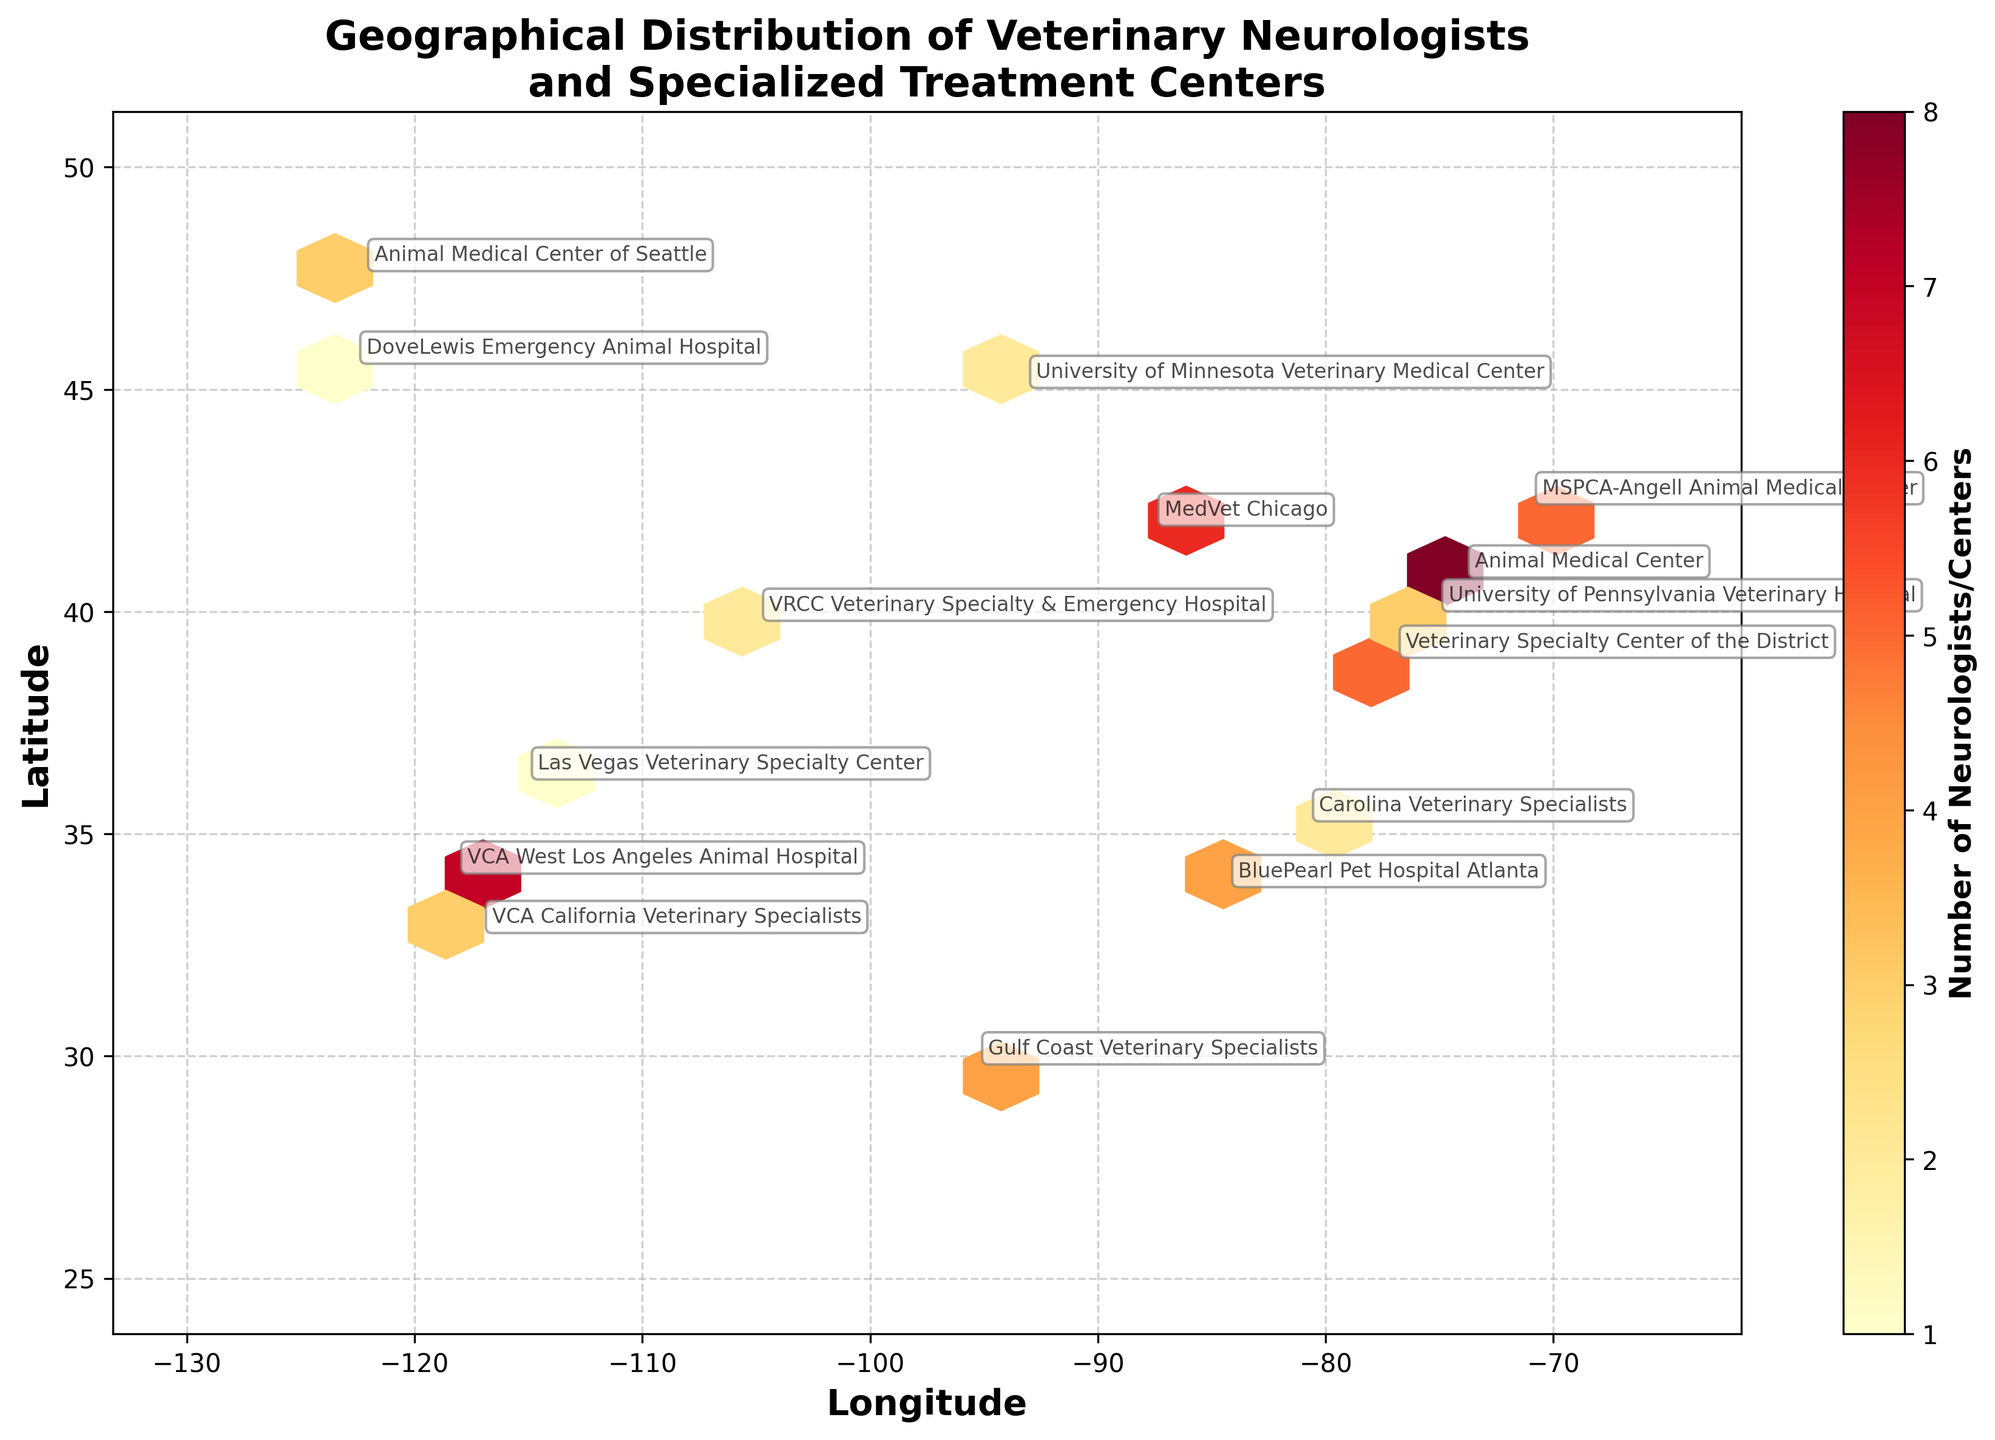What is the title of the figure? The title is typically located at the top of the figure and provides a brief description of what is being depicted. In this case, the title informs the viewer that the plot shows the geographical distribution of veterinary neurologists and specialized treatment centers for canine neurological disorders.
Answer: Geographical Distribution of Veterinary Neurologists and Specialized Treatment Centers What do the colors in the hexbin plot represent? The color intensity in a hexbin plot usually indicates the density or concentration of data points in a specific area. Here, darker colors likely represent a higher number of veterinary neurologists and specialized centers.
Answer: Number of Neurologists/Centers Which city has the highest concentration of veterinary neurologists and treatment centers? By identifying the darkest hexagon, which indicates the highest density, we can see that New York City (latitude 40.7128, longitude -74.0060) has the greatest concentration.
Answer: New York City How many centers are represented in Los Angeles according to the plot? By looking at the color gradient and annotations near Los Angeles (latitude 34.0522, longitude -118.2437), we find the label showing a number count.
Answer: 7 centers Which city shows a similar number of neurologists and treatment centers as Washington, D.C.? By comparing the data points, we can see that both Washington, D.C. (38.9072, -77.0369) and Boston (42.3601, -71.0589) have a count of 5, indicating a similar concentration.
Answer: Boston Are there more treatment centers on the East Coast or the West Coast? Summing the counts for cities like New York, Washington, D.C., Philadelphia, and Boston on the East Coast and comparing it with the counts for cities like Los Angeles, Seattle, San Diego, and Portland on the West Coast. The East Coast has more centers.
Answer: East Coast What is the hexagon grid size used in the plot, and how does it affect the visualization? The grid size parameter in a hexbin plot determines the number of hexagons used to divide the plot area; a smaller size would result in more hexagons and a finer resolution. The code specifies a grid size of 20.
Answer: 20; finer resolution Which regions appear to have very few or no veterinary neurologists or specialized treatment centers based on the hexbin plot? Areas with no or very light-colored hexagons, such as the central United States, indicate fewer or no data points, suggesting a lack of specialized centers.
Answer: Central United States Given the latitude and longitude annotations, which center is closest to the geographical location with coordinates (34.0522, -118.2437)? Finding the exact match of these coordinates in the annotations provided near Los Angeles, it corresponds to the "VCA West Los Angeles Animal Hospital".
Answer: VCA West Los Angeles Animal Hospital 